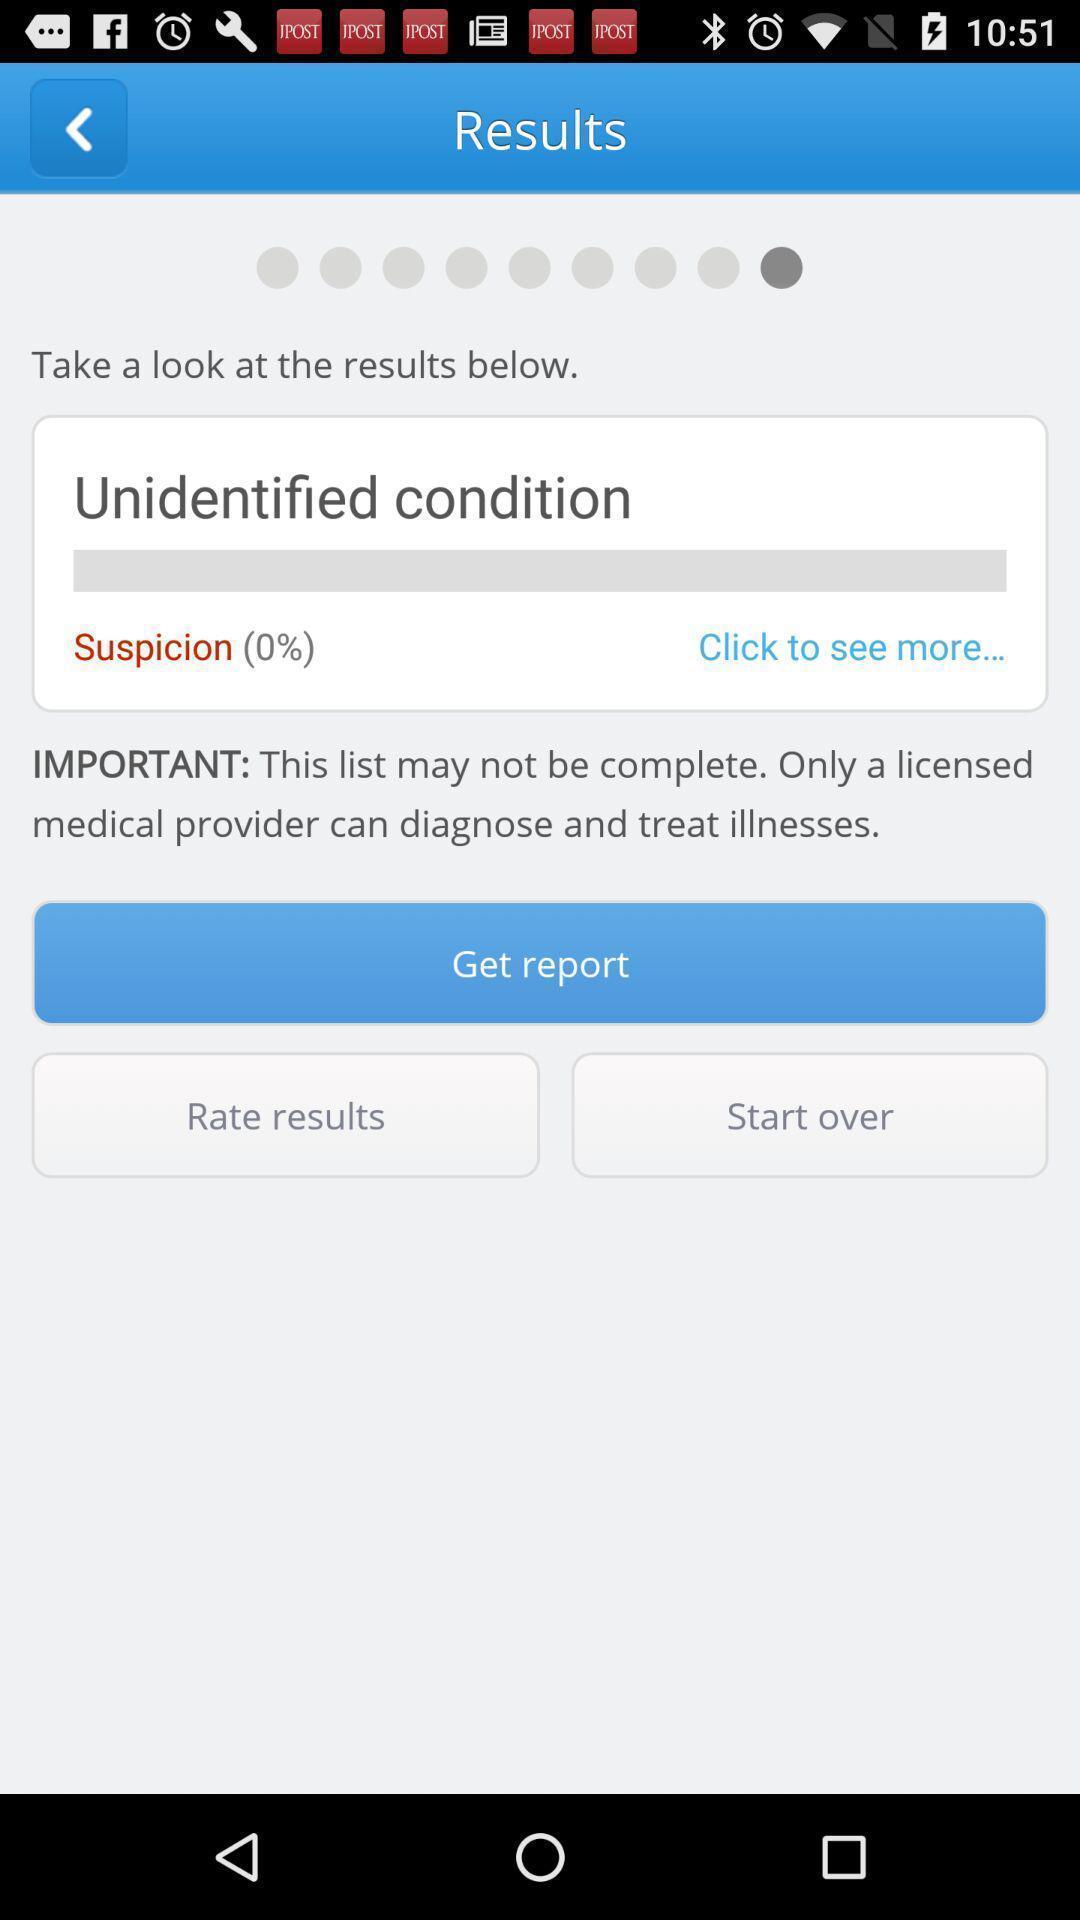Explain what's happening in this screen capture. Results page in a health app. 